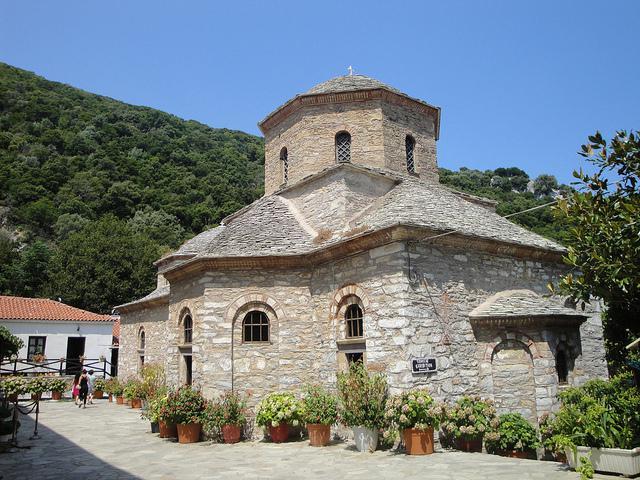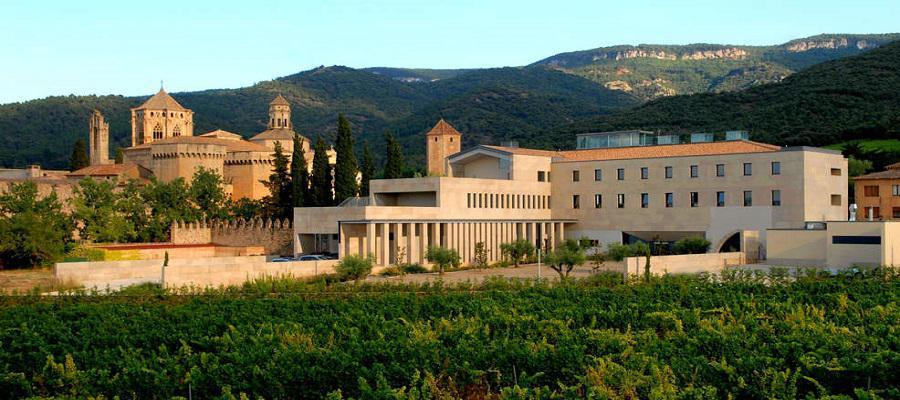The first image is the image on the left, the second image is the image on the right. For the images displayed, is the sentence "There is a building with a blue dome in at least one of the images." factually correct? Answer yes or no. No. The first image is the image on the left, the second image is the image on the right. Examine the images to the left and right. Is the description "An image shows people walking down a wide paved path toward a row of arches with a dome-topped tower behind them." accurate? Answer yes or no. No. 